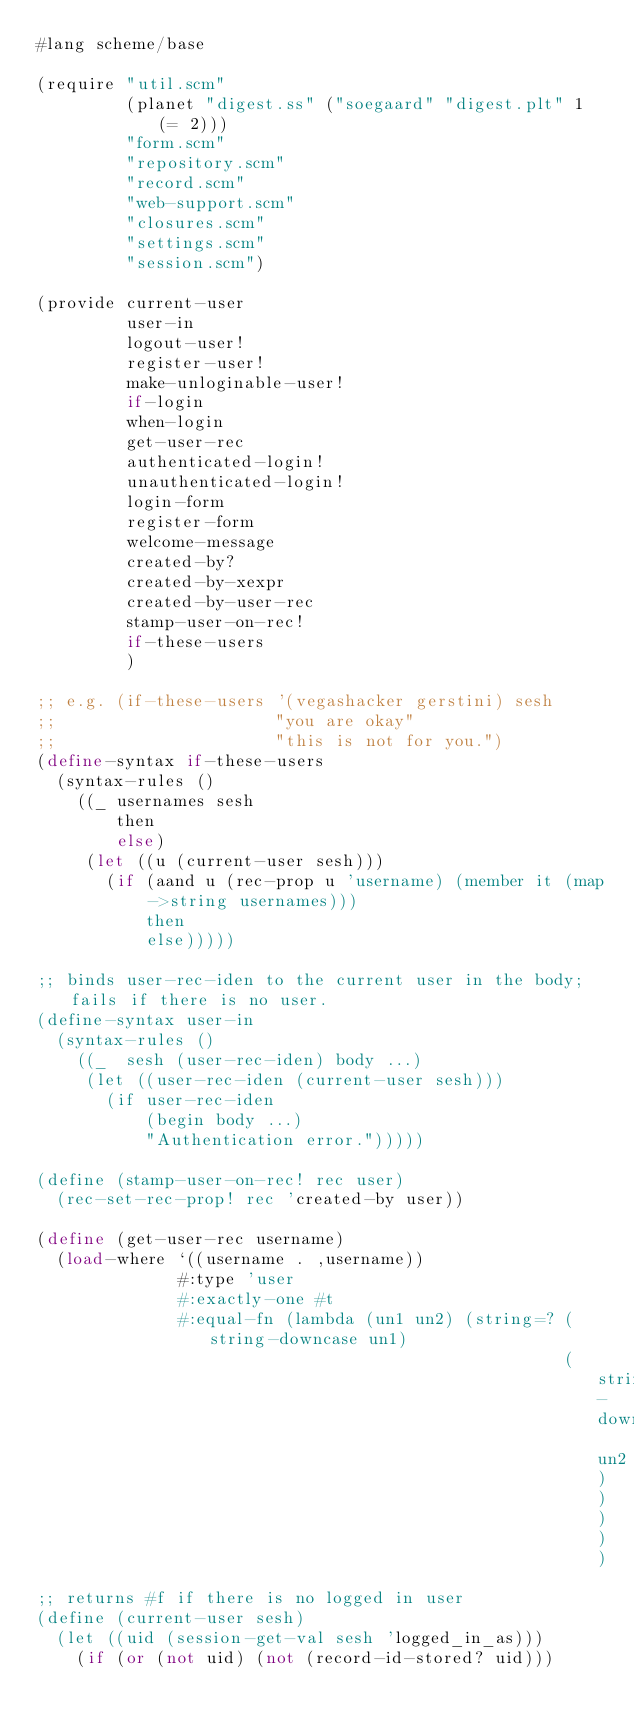Convert code to text. <code><loc_0><loc_0><loc_500><loc_500><_Scheme_>#lang scheme/base

(require "util.scm"
         (planet "digest.ss" ("soegaard" "digest.plt" 1 (= 2)))
         "form.scm"
         "repository.scm"
         "record.scm"
         "web-support.scm"
         "closures.scm"
         "settings.scm"
         "session.scm")

(provide current-user
         user-in
         logout-user!
         register-user!
         make-unloginable-user!
         if-login
         when-login
         get-user-rec
         authenticated-login!
         unauthenticated-login!
         login-form
         register-form
         welcome-message
         created-by?
         created-by-xexpr
         created-by-user-rec
         stamp-user-on-rec!
         if-these-users
         )

;; e.g. (if-these-users '(vegashacker gerstini) sesh
;;                      "you are okay"
;;                      "this is not for you.")
(define-syntax if-these-users
  (syntax-rules ()
    ((_ usernames sesh
        then
        else)
     (let ((u (current-user sesh)))
       (if (aand u (rec-prop u 'username) (member it (map ->string usernames)))
           then
           else)))))

;; binds user-rec-iden to the current user in the body; fails if there is no user.
(define-syntax user-in
  (syntax-rules ()
    ((_  sesh (user-rec-iden) body ...)
     (let ((user-rec-iden (current-user sesh)))
       (if user-rec-iden
           (begin body ...)
           "Authentication error.")))))

(define (stamp-user-on-rec! rec user)
  (rec-set-rec-prop! rec 'created-by user))

(define (get-user-rec username)
  (load-where `((username . ,username))
              #:type 'user
              #:exactly-one #t
              #:equal-fn (lambda (un1 un2) (string=? (string-downcase un1)
                                                     (string-downcase un2)))))

;; returns #f if there is no logged in user
(define (current-user sesh)
  (let ((uid (session-get-val sesh 'logged_in_as)))
    (if (or (not uid) (not (record-id-stored? uid)))</code> 